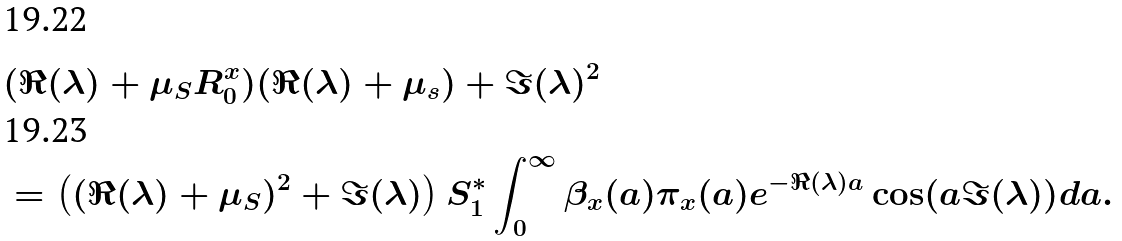<formula> <loc_0><loc_0><loc_500><loc_500>& ( \Re ( \lambda ) + \mu _ { S } R _ { 0 } ^ { x } ) ( \Re ( \lambda ) + \mu _ { s } ) + \Im ( \lambda ) ^ { 2 } \\ & = \left ( ( \Re ( \lambda ) + \mu _ { S } ) ^ { 2 } + \Im ( \lambda ) \right ) S ^ { * } _ { 1 } \int _ { 0 } ^ { \infty } \beta _ { x } ( a ) \pi _ { x } ( a ) e ^ { - \Re ( \lambda ) a } \cos ( a \Im ( \lambda ) ) d a .</formula> 